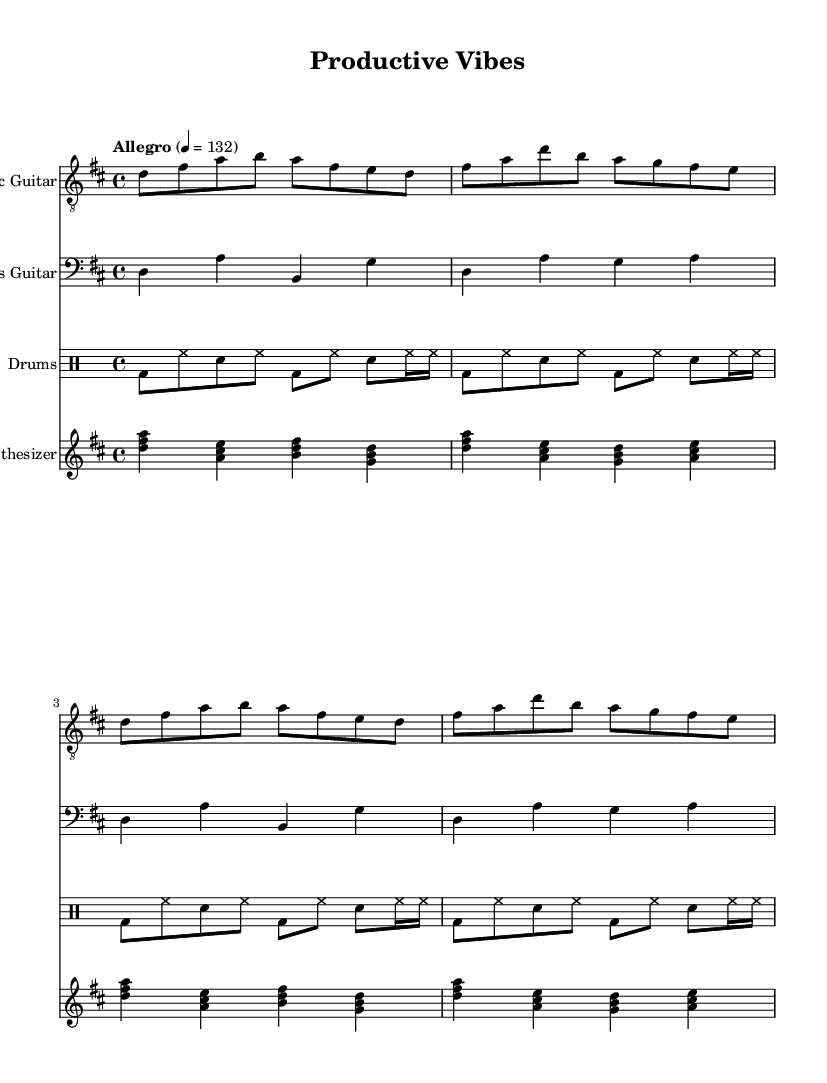What is the key signature of this music? The key signature is indicated at the beginning of the staff, showing two sharps (F# and C#), which confirms that the piece is in D major.
Answer: D major What is the time signature of this piece? The time signature is located at the beginning of the score, displaying a 4 over 4, which signifies that there are 4 beats in each measure.
Answer: 4/4 What is the tempo marking of this music? The tempo marking, found at the beginning of the score, indicates 'Allegro' with a metronome marking of 132 beats per minute, which suggests a fast pace.
Answer: Allegro 132 How many measures are there in the electric guitar part? By counting the number of groups separated by vertical bar lines in the electric guitar part, there are 8 measures present.
Answer: 8 What type of instrument is the synth part written for? The synth part is arranged for a piano staff, and synthesizers are typically played on piano keys. This is designated in the score explicitly as "Synthesizer."
Answer: Synthesizer Identify the rhythmic pattern played by the drums. Analyzing the drum part, it consistently features a pattern of bass drums and hi-hats, alternating with snare hits, creating a driving rock rhythm typical in upbeat tempos.
Answer: Bass and hi-hat alternating with snare Which instrument plays the higher melodic lines? Comparing the pitches of the parts, the electric guitar and synthesizer have higher melodic lines, with the electric guitar leading in melodic focus while synthesizer harmonizes. The electric guitar plays the main melody.
Answer: Electric guitar 